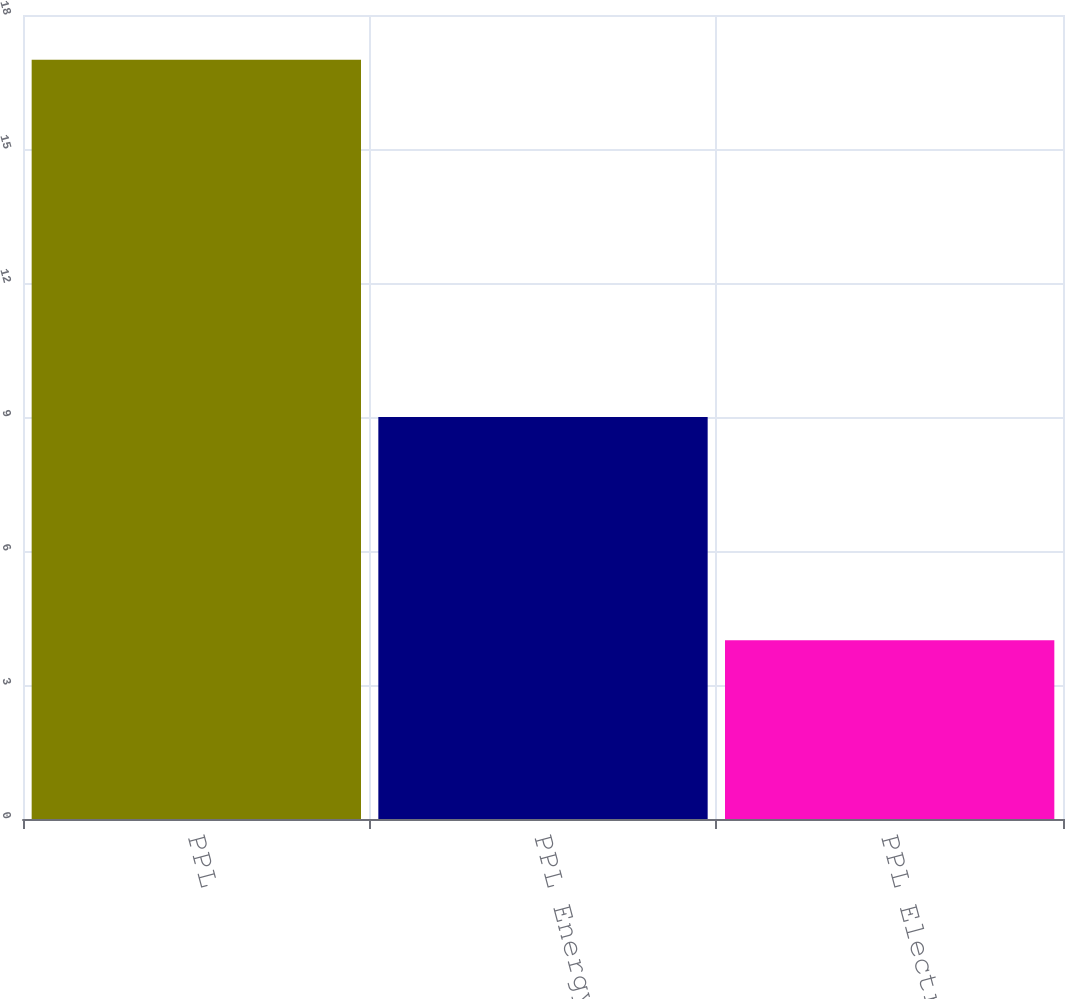Convert chart to OTSL. <chart><loc_0><loc_0><loc_500><loc_500><bar_chart><fcel>PPL<fcel>PPL Energy Supply<fcel>PPL Electric<nl><fcel>17<fcel>9<fcel>4<nl></chart> 